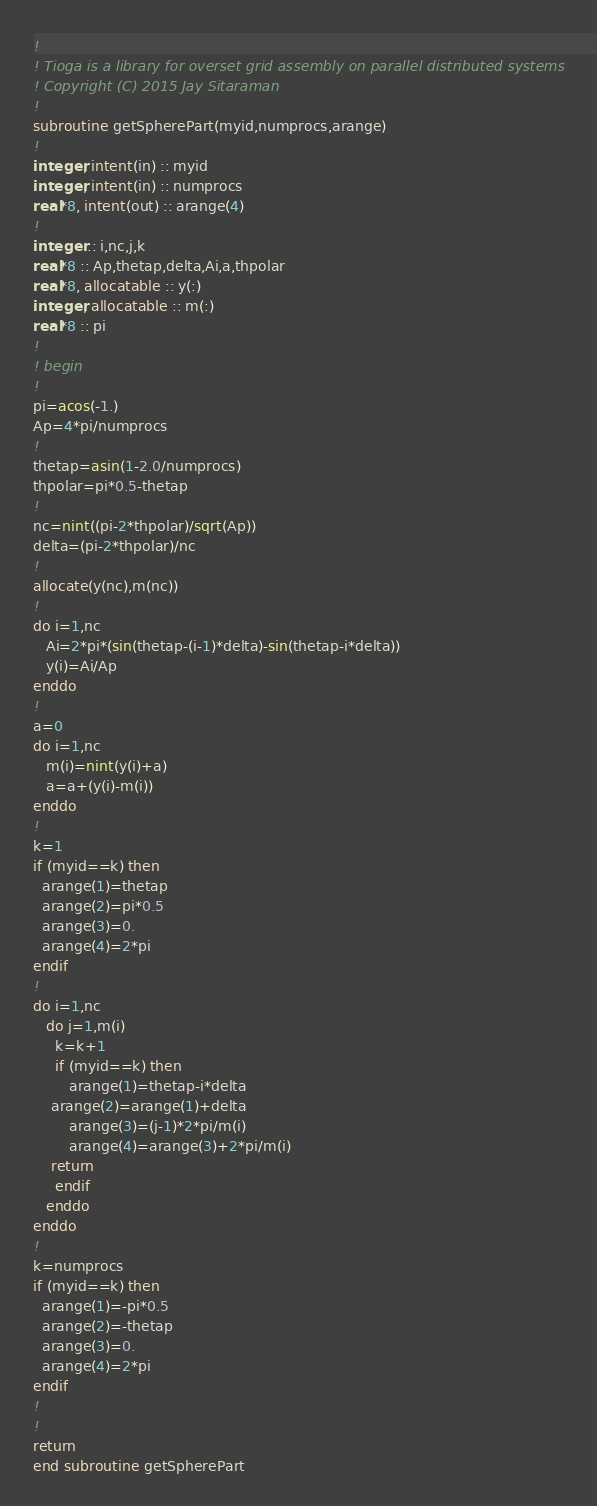Convert code to text. <code><loc_0><loc_0><loc_500><loc_500><_FORTRAN_>!
! Tioga is a library for overset grid assembly on parallel distributed systems
! Copyright (C) 2015 Jay Sitaraman
!
subroutine getSpherePart(myid,numprocs,arange)
!
integer, intent(in) :: myid
integer, intent(in) :: numprocs
real*8, intent(out) :: arange(4)
!
integer :: i,nc,j,k
real*8 :: Ap,thetap,delta,Ai,a,thpolar
real*8, allocatable :: y(:)
integer, allocatable :: m(:)
real*8 :: pi
!
! begin
!
pi=acos(-1.)
Ap=4*pi/numprocs
!
thetap=asin(1-2.0/numprocs)
thpolar=pi*0.5-thetap
!
nc=nint((pi-2*thpolar)/sqrt(Ap))
delta=(pi-2*thpolar)/nc
!
allocate(y(nc),m(nc))
!
do i=1,nc
   Ai=2*pi*(sin(thetap-(i-1)*delta)-sin(thetap-i*delta))
   y(i)=Ai/Ap
enddo
!
a=0
do i=1,nc
   m(i)=nint(y(i)+a)
   a=a+(y(i)-m(i))
enddo
!
k=1
if (myid==k) then
  arange(1)=thetap
  arange(2)=pi*0.5
  arange(3)=0.
  arange(4)=2*pi
endif
!
do i=1,nc
   do j=1,m(i)
     k=k+1
     if (myid==k) then
        arange(1)=thetap-i*delta
	arange(2)=arange(1)+delta
        arange(3)=(j-1)*2*pi/m(i)
        arange(4)=arange(3)+2*pi/m(i)
	return
     endif
   enddo
enddo
!
k=numprocs
if (myid==k) then
  arange(1)=-pi*0.5
  arange(2)=-thetap
  arange(3)=0.
  arange(4)=2*pi
endif
!
!
return
end subroutine getSpherePart
</code> 